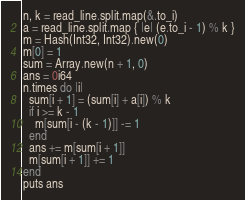Convert code to text. <code><loc_0><loc_0><loc_500><loc_500><_Crystal_>n, k = read_line.split.map(&.to_i)
a = read_line.split.map { |e| (e.to_i - 1) % k }
m = Hash(Int32, Int32).new(0)
m[0] = 1
sum = Array.new(n + 1, 0)
ans = 0i64
n.times do |i|
  sum[i + 1] = (sum[i] + a[i]) % k
  if i >= k - 1
    m[sum[i - (k - 1)]] -= 1
  end
  ans += m[sum[i + 1]]
  m[sum[i + 1]] += 1
end
puts ans
</code> 